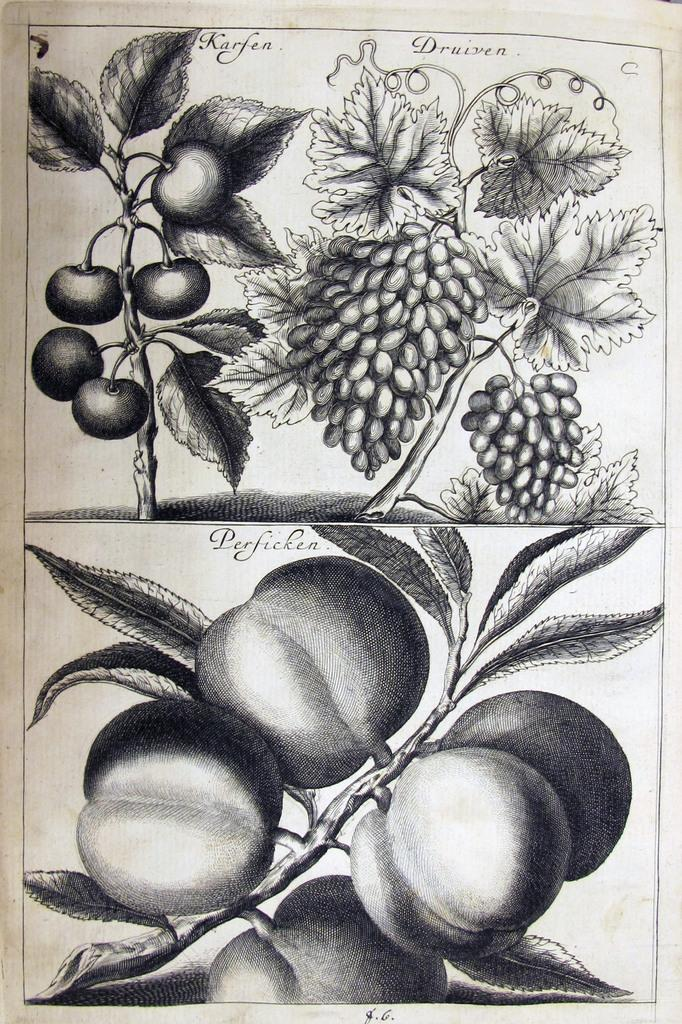What medium is used to create the image? The image is a pencil art on paper. What types of produce are depicted in the art? There are grapes and tomatoes in the art. How are the fruits or vegetables arranged in the art? They are hanging from plants in the art. What type of umbrella is being used to protect the tomatoes from the clouds in the image? There is no umbrella or clouds present in the image; it is a pencil art featuring grapes and tomatoes hanging from plants. 